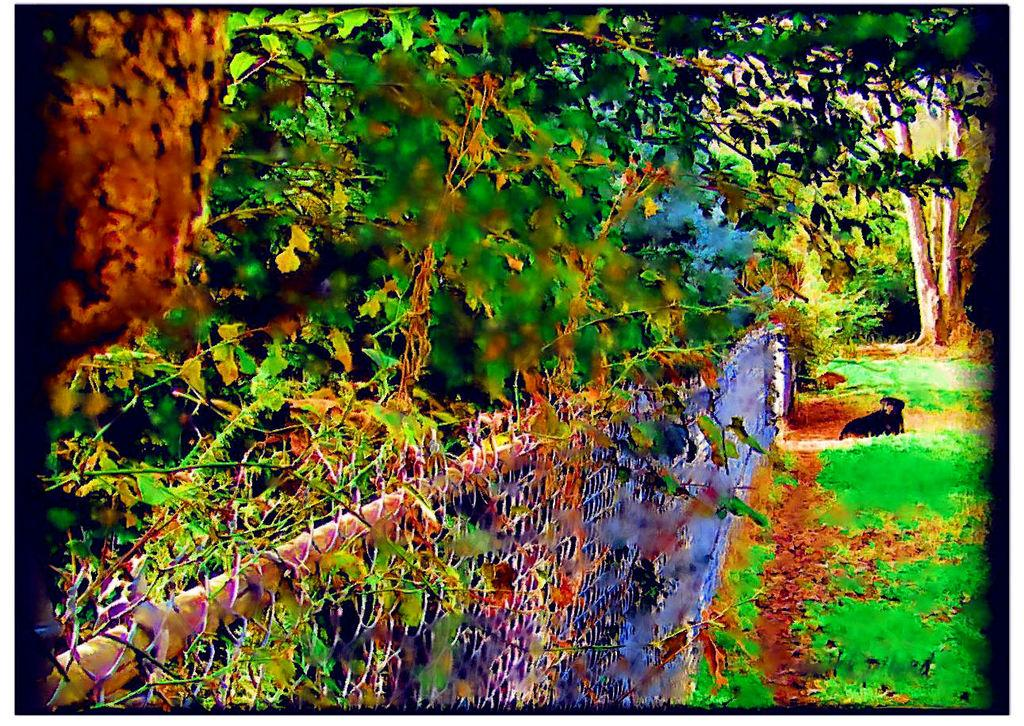What type of vegetation can be seen in the image? There are trees in the image. What is covering the ground in the image? There is grass on the ground in the image. What type of fence is present in the image? There is a metal fence in the image. What animal can be seen in the image? There is a dog in the image. What type of crime is being committed by the frogs in the image? There are no frogs present in the image, so it is not possible to determine if any crime is being committed by them. 